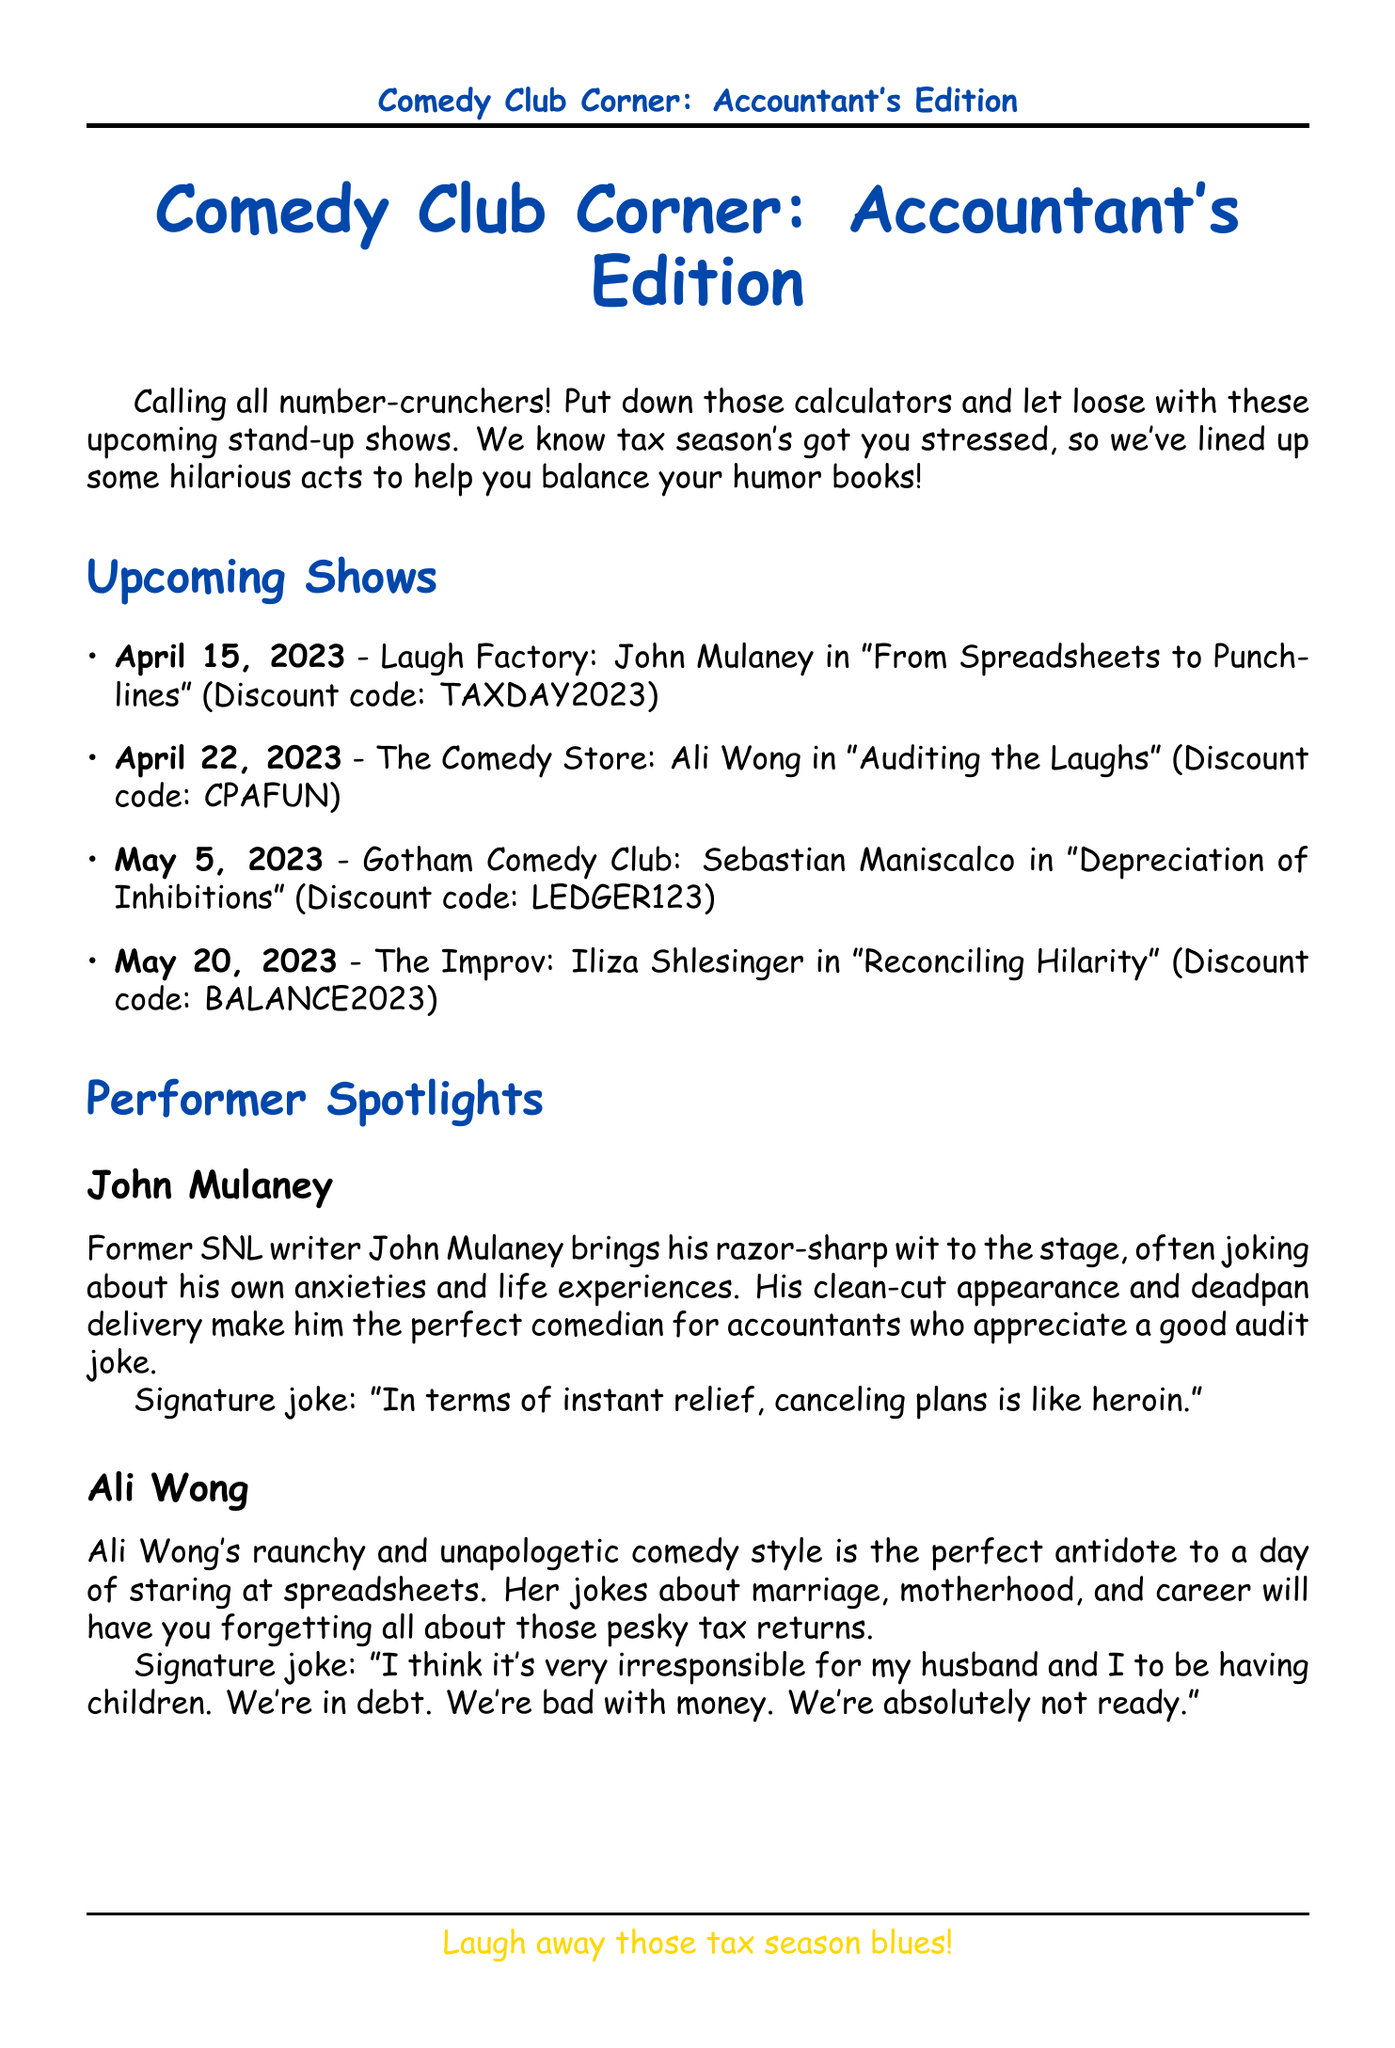What is the title of the newsletter? The title is found in the document header and gives an overview of the content for accountants.
Answer: Comedy Club Corner: Accountant's Edition When is John Mulaney performing? The date is detailed in the calendar of events and is important for planning attendance.
Answer: April 15, 2023 What venue will Iliza Shlesinger be at? The venue is listed in the calendar, which provides information on where to attend the shows.
Answer: The Improv What is the discount code for Ali Wong's show? This information helps accountants access discounts on tickets as indicated in the event details.
Answer: CPAFUN What is the signature joke of Sebastian Maniscalco? The signature joke provides insight into the comedian's style and humor relevant to the audience's interests.
Answer: Not provided What special offer is available for accountants? The exclusive offer highlights a promotion related to the shows, encouraging attendance.
Answer: Comedy & Cocktails Package How can accountants submit a joke? The reader submission section gives details on participation for additional engagement with the newsletter.
Answer: Submit a funny accounting joke What is the stress relief tip mentioned in the newsletter? This tip provides a practical way for accountants to unwind, reflecting the newsletter's supportive tone.
Answer: Laughter Yoga for Accountants Who is the target audience of this newsletter? The audience is specified at the beginning of the document, clarifying who the content is tailored for.
Answer: Accountants 